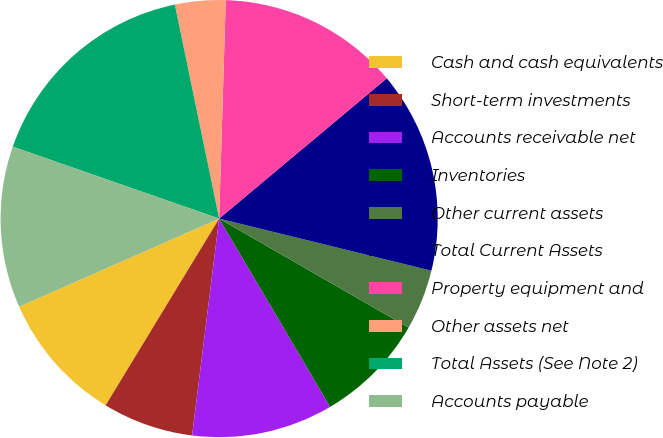Convert chart to OTSL. <chart><loc_0><loc_0><loc_500><loc_500><pie_chart><fcel>Cash and cash equivalents<fcel>Short-term investments<fcel>Accounts receivable net<fcel>Inventories<fcel>Other current assets<fcel>Total Current Assets<fcel>Property equipment and<fcel>Other assets net<fcel>Total Assets (See Note 2)<fcel>Accounts payable<nl><fcel>9.7%<fcel>6.72%<fcel>10.45%<fcel>8.21%<fcel>4.48%<fcel>14.92%<fcel>13.43%<fcel>3.73%<fcel>16.41%<fcel>11.94%<nl></chart> 